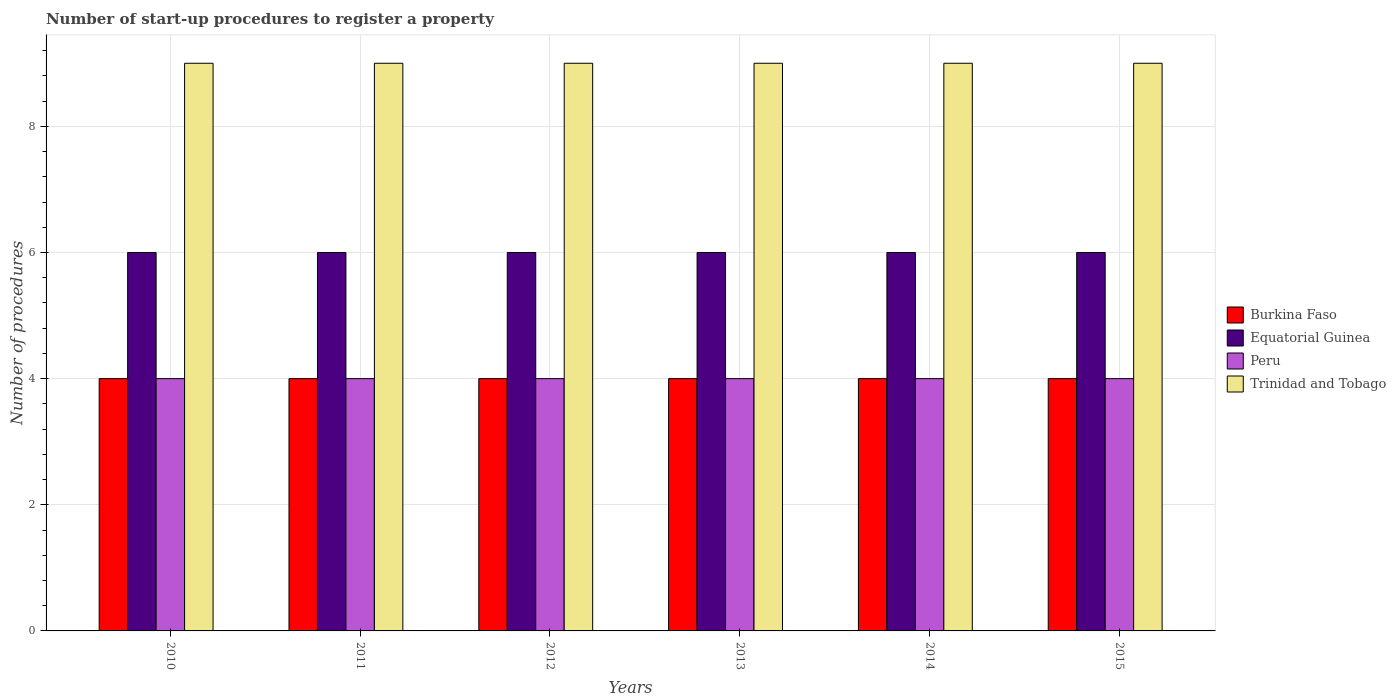How many groups of bars are there?
Give a very brief answer. 6. Are the number of bars on each tick of the X-axis equal?
Make the answer very short. Yes. What is the label of the 6th group of bars from the left?
Provide a short and direct response. 2015. Across all years, what is the maximum number of procedures required to register a property in Peru?
Provide a short and direct response. 4. Across all years, what is the minimum number of procedures required to register a property in Trinidad and Tobago?
Your response must be concise. 9. In which year was the number of procedures required to register a property in Equatorial Guinea minimum?
Offer a terse response. 2010. What is the total number of procedures required to register a property in Peru in the graph?
Keep it short and to the point. 24. What is the difference between the number of procedures required to register a property in Trinidad and Tobago in 2010 and that in 2014?
Provide a succinct answer. 0. In the year 2010, what is the difference between the number of procedures required to register a property in Trinidad and Tobago and number of procedures required to register a property in Peru?
Offer a terse response. 5. In how many years, is the number of procedures required to register a property in Trinidad and Tobago greater than 4.8?
Ensure brevity in your answer.  6. Is the difference between the number of procedures required to register a property in Trinidad and Tobago in 2013 and 2015 greater than the difference between the number of procedures required to register a property in Peru in 2013 and 2015?
Your response must be concise. No. What is the difference between the highest and the lowest number of procedures required to register a property in Peru?
Provide a short and direct response. 0. Is the sum of the number of procedures required to register a property in Peru in 2010 and 2014 greater than the maximum number of procedures required to register a property in Equatorial Guinea across all years?
Make the answer very short. Yes. Is it the case that in every year, the sum of the number of procedures required to register a property in Burkina Faso and number of procedures required to register a property in Trinidad and Tobago is greater than the sum of number of procedures required to register a property in Equatorial Guinea and number of procedures required to register a property in Peru?
Provide a succinct answer. Yes. What does the 2nd bar from the left in 2010 represents?
Ensure brevity in your answer.  Equatorial Guinea. What does the 4th bar from the right in 2014 represents?
Provide a short and direct response. Burkina Faso. How many bars are there?
Your answer should be compact. 24. How many years are there in the graph?
Make the answer very short. 6. What is the difference between two consecutive major ticks on the Y-axis?
Make the answer very short. 2. How many legend labels are there?
Provide a succinct answer. 4. What is the title of the graph?
Offer a very short reply. Number of start-up procedures to register a property. Does "Central Europe" appear as one of the legend labels in the graph?
Offer a terse response. No. What is the label or title of the X-axis?
Your response must be concise. Years. What is the label or title of the Y-axis?
Give a very brief answer. Number of procedures. What is the Number of procedures of Burkina Faso in 2010?
Your answer should be very brief. 4. What is the Number of procedures of Equatorial Guinea in 2010?
Offer a very short reply. 6. What is the Number of procedures of Peru in 2010?
Provide a succinct answer. 4. What is the Number of procedures of Trinidad and Tobago in 2010?
Your answer should be compact. 9. What is the Number of procedures in Peru in 2011?
Offer a very short reply. 4. What is the Number of procedures in Trinidad and Tobago in 2011?
Offer a very short reply. 9. What is the Number of procedures in Equatorial Guinea in 2013?
Offer a very short reply. 6. What is the Number of procedures of Trinidad and Tobago in 2013?
Provide a short and direct response. 9. What is the Number of procedures of Equatorial Guinea in 2014?
Give a very brief answer. 6. What is the Number of procedures in Peru in 2014?
Keep it short and to the point. 4. What is the Number of procedures in Burkina Faso in 2015?
Offer a very short reply. 4. What is the Number of procedures of Equatorial Guinea in 2015?
Offer a terse response. 6. What is the Number of procedures of Peru in 2015?
Your answer should be very brief. 4. Across all years, what is the minimum Number of procedures in Trinidad and Tobago?
Give a very brief answer. 9. What is the total Number of procedures in Burkina Faso in the graph?
Ensure brevity in your answer.  24. What is the total Number of procedures in Equatorial Guinea in the graph?
Your answer should be very brief. 36. What is the total Number of procedures of Peru in the graph?
Keep it short and to the point. 24. What is the difference between the Number of procedures in Equatorial Guinea in 2010 and that in 2011?
Give a very brief answer. 0. What is the difference between the Number of procedures in Peru in 2010 and that in 2011?
Your answer should be very brief. 0. What is the difference between the Number of procedures in Trinidad and Tobago in 2010 and that in 2011?
Your response must be concise. 0. What is the difference between the Number of procedures in Burkina Faso in 2010 and that in 2012?
Your response must be concise. 0. What is the difference between the Number of procedures in Equatorial Guinea in 2010 and that in 2012?
Your answer should be compact. 0. What is the difference between the Number of procedures in Peru in 2010 and that in 2012?
Keep it short and to the point. 0. What is the difference between the Number of procedures in Trinidad and Tobago in 2010 and that in 2012?
Keep it short and to the point. 0. What is the difference between the Number of procedures of Burkina Faso in 2010 and that in 2013?
Offer a very short reply. 0. What is the difference between the Number of procedures in Equatorial Guinea in 2010 and that in 2013?
Provide a short and direct response. 0. What is the difference between the Number of procedures of Burkina Faso in 2010 and that in 2014?
Ensure brevity in your answer.  0. What is the difference between the Number of procedures in Equatorial Guinea in 2010 and that in 2014?
Keep it short and to the point. 0. What is the difference between the Number of procedures in Equatorial Guinea in 2010 and that in 2015?
Give a very brief answer. 0. What is the difference between the Number of procedures of Peru in 2011 and that in 2012?
Ensure brevity in your answer.  0. What is the difference between the Number of procedures in Trinidad and Tobago in 2011 and that in 2014?
Offer a terse response. 0. What is the difference between the Number of procedures in Equatorial Guinea in 2011 and that in 2015?
Your response must be concise. 0. What is the difference between the Number of procedures in Peru in 2011 and that in 2015?
Offer a terse response. 0. What is the difference between the Number of procedures in Burkina Faso in 2012 and that in 2013?
Offer a very short reply. 0. What is the difference between the Number of procedures of Equatorial Guinea in 2012 and that in 2013?
Give a very brief answer. 0. What is the difference between the Number of procedures of Peru in 2012 and that in 2013?
Your answer should be very brief. 0. What is the difference between the Number of procedures of Burkina Faso in 2012 and that in 2014?
Provide a short and direct response. 0. What is the difference between the Number of procedures in Burkina Faso in 2012 and that in 2015?
Offer a very short reply. 0. What is the difference between the Number of procedures of Equatorial Guinea in 2012 and that in 2015?
Provide a short and direct response. 0. What is the difference between the Number of procedures in Trinidad and Tobago in 2012 and that in 2015?
Give a very brief answer. 0. What is the difference between the Number of procedures of Burkina Faso in 2013 and that in 2014?
Ensure brevity in your answer.  0. What is the difference between the Number of procedures of Burkina Faso in 2013 and that in 2015?
Offer a terse response. 0. What is the difference between the Number of procedures in Equatorial Guinea in 2013 and that in 2015?
Your answer should be compact. 0. What is the difference between the Number of procedures of Peru in 2013 and that in 2015?
Provide a short and direct response. 0. What is the difference between the Number of procedures in Trinidad and Tobago in 2013 and that in 2015?
Your answer should be very brief. 0. What is the difference between the Number of procedures in Burkina Faso in 2014 and that in 2015?
Your answer should be compact. 0. What is the difference between the Number of procedures in Peru in 2014 and that in 2015?
Offer a very short reply. 0. What is the difference between the Number of procedures in Trinidad and Tobago in 2014 and that in 2015?
Offer a very short reply. 0. What is the difference between the Number of procedures in Burkina Faso in 2010 and the Number of procedures in Equatorial Guinea in 2011?
Provide a succinct answer. -2. What is the difference between the Number of procedures in Peru in 2010 and the Number of procedures in Trinidad and Tobago in 2011?
Ensure brevity in your answer.  -5. What is the difference between the Number of procedures of Burkina Faso in 2010 and the Number of procedures of Equatorial Guinea in 2012?
Provide a short and direct response. -2. What is the difference between the Number of procedures in Burkina Faso in 2010 and the Number of procedures in Peru in 2012?
Provide a short and direct response. 0. What is the difference between the Number of procedures of Burkina Faso in 2010 and the Number of procedures of Trinidad and Tobago in 2012?
Keep it short and to the point. -5. What is the difference between the Number of procedures of Equatorial Guinea in 2010 and the Number of procedures of Peru in 2012?
Ensure brevity in your answer.  2. What is the difference between the Number of procedures of Equatorial Guinea in 2010 and the Number of procedures of Trinidad and Tobago in 2012?
Your answer should be very brief. -3. What is the difference between the Number of procedures of Burkina Faso in 2010 and the Number of procedures of Peru in 2013?
Keep it short and to the point. 0. What is the difference between the Number of procedures in Burkina Faso in 2010 and the Number of procedures in Trinidad and Tobago in 2013?
Keep it short and to the point. -5. What is the difference between the Number of procedures of Burkina Faso in 2010 and the Number of procedures of Equatorial Guinea in 2014?
Provide a succinct answer. -2. What is the difference between the Number of procedures of Burkina Faso in 2010 and the Number of procedures of Peru in 2014?
Your response must be concise. 0. What is the difference between the Number of procedures in Burkina Faso in 2010 and the Number of procedures in Trinidad and Tobago in 2014?
Your answer should be compact. -5. What is the difference between the Number of procedures of Peru in 2010 and the Number of procedures of Trinidad and Tobago in 2014?
Your answer should be very brief. -5. What is the difference between the Number of procedures of Burkina Faso in 2010 and the Number of procedures of Equatorial Guinea in 2015?
Keep it short and to the point. -2. What is the difference between the Number of procedures of Burkina Faso in 2010 and the Number of procedures of Peru in 2015?
Make the answer very short. 0. What is the difference between the Number of procedures in Burkina Faso in 2010 and the Number of procedures in Trinidad and Tobago in 2015?
Offer a very short reply. -5. What is the difference between the Number of procedures of Equatorial Guinea in 2010 and the Number of procedures of Trinidad and Tobago in 2015?
Your response must be concise. -3. What is the difference between the Number of procedures in Peru in 2010 and the Number of procedures in Trinidad and Tobago in 2015?
Make the answer very short. -5. What is the difference between the Number of procedures of Burkina Faso in 2011 and the Number of procedures of Peru in 2012?
Keep it short and to the point. 0. What is the difference between the Number of procedures in Equatorial Guinea in 2011 and the Number of procedures in Peru in 2012?
Your answer should be compact. 2. What is the difference between the Number of procedures in Equatorial Guinea in 2011 and the Number of procedures in Trinidad and Tobago in 2012?
Offer a very short reply. -3. What is the difference between the Number of procedures of Peru in 2011 and the Number of procedures of Trinidad and Tobago in 2012?
Provide a succinct answer. -5. What is the difference between the Number of procedures of Burkina Faso in 2011 and the Number of procedures of Peru in 2013?
Provide a short and direct response. 0. What is the difference between the Number of procedures in Burkina Faso in 2011 and the Number of procedures in Trinidad and Tobago in 2013?
Offer a terse response. -5. What is the difference between the Number of procedures of Equatorial Guinea in 2011 and the Number of procedures of Trinidad and Tobago in 2013?
Your response must be concise. -3. What is the difference between the Number of procedures in Peru in 2011 and the Number of procedures in Trinidad and Tobago in 2013?
Offer a very short reply. -5. What is the difference between the Number of procedures in Burkina Faso in 2011 and the Number of procedures in Equatorial Guinea in 2014?
Your answer should be very brief. -2. What is the difference between the Number of procedures of Burkina Faso in 2011 and the Number of procedures of Peru in 2014?
Your answer should be compact. 0. What is the difference between the Number of procedures of Equatorial Guinea in 2011 and the Number of procedures of Peru in 2014?
Offer a very short reply. 2. What is the difference between the Number of procedures of Equatorial Guinea in 2011 and the Number of procedures of Trinidad and Tobago in 2014?
Provide a short and direct response. -3. What is the difference between the Number of procedures of Burkina Faso in 2011 and the Number of procedures of Equatorial Guinea in 2015?
Provide a short and direct response. -2. What is the difference between the Number of procedures of Burkina Faso in 2011 and the Number of procedures of Peru in 2015?
Offer a very short reply. 0. What is the difference between the Number of procedures of Equatorial Guinea in 2011 and the Number of procedures of Peru in 2015?
Provide a short and direct response. 2. What is the difference between the Number of procedures in Equatorial Guinea in 2011 and the Number of procedures in Trinidad and Tobago in 2015?
Your answer should be compact. -3. What is the difference between the Number of procedures in Peru in 2011 and the Number of procedures in Trinidad and Tobago in 2015?
Provide a succinct answer. -5. What is the difference between the Number of procedures in Burkina Faso in 2012 and the Number of procedures in Equatorial Guinea in 2013?
Offer a very short reply. -2. What is the difference between the Number of procedures of Burkina Faso in 2012 and the Number of procedures of Trinidad and Tobago in 2013?
Your answer should be compact. -5. What is the difference between the Number of procedures in Equatorial Guinea in 2012 and the Number of procedures in Trinidad and Tobago in 2013?
Keep it short and to the point. -3. What is the difference between the Number of procedures of Burkina Faso in 2012 and the Number of procedures of Equatorial Guinea in 2014?
Offer a very short reply. -2. What is the difference between the Number of procedures in Burkina Faso in 2012 and the Number of procedures in Peru in 2014?
Keep it short and to the point. 0. What is the difference between the Number of procedures of Equatorial Guinea in 2012 and the Number of procedures of Trinidad and Tobago in 2014?
Your response must be concise. -3. What is the difference between the Number of procedures in Equatorial Guinea in 2012 and the Number of procedures in Peru in 2015?
Give a very brief answer. 2. What is the difference between the Number of procedures of Burkina Faso in 2013 and the Number of procedures of Equatorial Guinea in 2014?
Ensure brevity in your answer.  -2. What is the difference between the Number of procedures of Equatorial Guinea in 2013 and the Number of procedures of Peru in 2014?
Provide a succinct answer. 2. What is the difference between the Number of procedures in Equatorial Guinea in 2013 and the Number of procedures in Trinidad and Tobago in 2014?
Your answer should be very brief. -3. What is the difference between the Number of procedures in Peru in 2013 and the Number of procedures in Trinidad and Tobago in 2014?
Your answer should be very brief. -5. What is the difference between the Number of procedures in Burkina Faso in 2013 and the Number of procedures in Peru in 2015?
Your response must be concise. 0. What is the difference between the Number of procedures in Equatorial Guinea in 2013 and the Number of procedures in Peru in 2015?
Your answer should be compact. 2. What is the difference between the Number of procedures of Peru in 2013 and the Number of procedures of Trinidad and Tobago in 2015?
Your answer should be very brief. -5. What is the difference between the Number of procedures of Burkina Faso in 2014 and the Number of procedures of Peru in 2015?
Ensure brevity in your answer.  0. What is the difference between the Number of procedures of Burkina Faso in 2014 and the Number of procedures of Trinidad and Tobago in 2015?
Provide a succinct answer. -5. What is the average Number of procedures in Burkina Faso per year?
Offer a terse response. 4. What is the average Number of procedures of Trinidad and Tobago per year?
Keep it short and to the point. 9. In the year 2010, what is the difference between the Number of procedures in Burkina Faso and Number of procedures in Equatorial Guinea?
Make the answer very short. -2. In the year 2010, what is the difference between the Number of procedures in Burkina Faso and Number of procedures in Peru?
Your answer should be compact. 0. In the year 2010, what is the difference between the Number of procedures in Equatorial Guinea and Number of procedures in Peru?
Offer a very short reply. 2. In the year 2010, what is the difference between the Number of procedures of Equatorial Guinea and Number of procedures of Trinidad and Tobago?
Provide a short and direct response. -3. In the year 2010, what is the difference between the Number of procedures in Peru and Number of procedures in Trinidad and Tobago?
Offer a terse response. -5. In the year 2011, what is the difference between the Number of procedures in Burkina Faso and Number of procedures in Equatorial Guinea?
Offer a terse response. -2. In the year 2011, what is the difference between the Number of procedures of Burkina Faso and Number of procedures of Trinidad and Tobago?
Your answer should be very brief. -5. In the year 2011, what is the difference between the Number of procedures of Equatorial Guinea and Number of procedures of Trinidad and Tobago?
Keep it short and to the point. -3. In the year 2011, what is the difference between the Number of procedures of Peru and Number of procedures of Trinidad and Tobago?
Offer a terse response. -5. In the year 2012, what is the difference between the Number of procedures of Burkina Faso and Number of procedures of Trinidad and Tobago?
Offer a very short reply. -5. In the year 2012, what is the difference between the Number of procedures in Equatorial Guinea and Number of procedures in Trinidad and Tobago?
Offer a very short reply. -3. In the year 2012, what is the difference between the Number of procedures of Peru and Number of procedures of Trinidad and Tobago?
Offer a very short reply. -5. In the year 2013, what is the difference between the Number of procedures in Burkina Faso and Number of procedures in Equatorial Guinea?
Provide a succinct answer. -2. In the year 2013, what is the difference between the Number of procedures of Equatorial Guinea and Number of procedures of Peru?
Keep it short and to the point. 2. In the year 2014, what is the difference between the Number of procedures in Burkina Faso and Number of procedures in Equatorial Guinea?
Provide a short and direct response. -2. In the year 2014, what is the difference between the Number of procedures in Equatorial Guinea and Number of procedures in Trinidad and Tobago?
Your answer should be compact. -3. In the year 2014, what is the difference between the Number of procedures in Peru and Number of procedures in Trinidad and Tobago?
Offer a very short reply. -5. In the year 2015, what is the difference between the Number of procedures of Burkina Faso and Number of procedures of Peru?
Ensure brevity in your answer.  0. In the year 2015, what is the difference between the Number of procedures of Equatorial Guinea and Number of procedures of Peru?
Give a very brief answer. 2. In the year 2015, what is the difference between the Number of procedures in Equatorial Guinea and Number of procedures in Trinidad and Tobago?
Your answer should be compact. -3. In the year 2015, what is the difference between the Number of procedures in Peru and Number of procedures in Trinidad and Tobago?
Give a very brief answer. -5. What is the ratio of the Number of procedures in Equatorial Guinea in 2010 to that in 2011?
Provide a succinct answer. 1. What is the ratio of the Number of procedures in Trinidad and Tobago in 2010 to that in 2011?
Ensure brevity in your answer.  1. What is the ratio of the Number of procedures of Burkina Faso in 2010 to that in 2012?
Offer a terse response. 1. What is the ratio of the Number of procedures of Equatorial Guinea in 2010 to that in 2012?
Make the answer very short. 1. What is the ratio of the Number of procedures in Peru in 2010 to that in 2012?
Your response must be concise. 1. What is the ratio of the Number of procedures in Trinidad and Tobago in 2010 to that in 2012?
Offer a terse response. 1. What is the ratio of the Number of procedures of Burkina Faso in 2010 to that in 2013?
Your response must be concise. 1. What is the ratio of the Number of procedures of Peru in 2010 to that in 2013?
Provide a short and direct response. 1. What is the ratio of the Number of procedures in Trinidad and Tobago in 2010 to that in 2013?
Offer a terse response. 1. What is the ratio of the Number of procedures in Equatorial Guinea in 2010 to that in 2015?
Give a very brief answer. 1. What is the ratio of the Number of procedures of Peru in 2010 to that in 2015?
Provide a short and direct response. 1. What is the ratio of the Number of procedures of Trinidad and Tobago in 2010 to that in 2015?
Give a very brief answer. 1. What is the ratio of the Number of procedures of Equatorial Guinea in 2011 to that in 2012?
Keep it short and to the point. 1. What is the ratio of the Number of procedures of Peru in 2011 to that in 2012?
Make the answer very short. 1. What is the ratio of the Number of procedures of Trinidad and Tobago in 2011 to that in 2012?
Your answer should be very brief. 1. What is the ratio of the Number of procedures of Equatorial Guinea in 2011 to that in 2013?
Offer a terse response. 1. What is the ratio of the Number of procedures of Trinidad and Tobago in 2011 to that in 2014?
Provide a short and direct response. 1. What is the ratio of the Number of procedures in Burkina Faso in 2011 to that in 2015?
Offer a terse response. 1. What is the ratio of the Number of procedures in Equatorial Guinea in 2011 to that in 2015?
Provide a short and direct response. 1. What is the ratio of the Number of procedures in Peru in 2011 to that in 2015?
Your response must be concise. 1. What is the ratio of the Number of procedures of Trinidad and Tobago in 2011 to that in 2015?
Provide a short and direct response. 1. What is the ratio of the Number of procedures in Burkina Faso in 2012 to that in 2013?
Provide a short and direct response. 1. What is the ratio of the Number of procedures of Equatorial Guinea in 2012 to that in 2013?
Keep it short and to the point. 1. What is the ratio of the Number of procedures in Peru in 2012 to that in 2013?
Ensure brevity in your answer.  1. What is the ratio of the Number of procedures of Equatorial Guinea in 2012 to that in 2014?
Make the answer very short. 1. What is the ratio of the Number of procedures of Trinidad and Tobago in 2012 to that in 2014?
Keep it short and to the point. 1. What is the ratio of the Number of procedures in Peru in 2012 to that in 2015?
Ensure brevity in your answer.  1. What is the ratio of the Number of procedures of Trinidad and Tobago in 2012 to that in 2015?
Your answer should be compact. 1. What is the ratio of the Number of procedures of Equatorial Guinea in 2013 to that in 2014?
Provide a succinct answer. 1. What is the ratio of the Number of procedures in Peru in 2013 to that in 2014?
Provide a succinct answer. 1. What is the ratio of the Number of procedures of Trinidad and Tobago in 2013 to that in 2014?
Provide a succinct answer. 1. What is the ratio of the Number of procedures of Burkina Faso in 2013 to that in 2015?
Provide a short and direct response. 1. What is the ratio of the Number of procedures of Equatorial Guinea in 2013 to that in 2015?
Offer a very short reply. 1. What is the ratio of the Number of procedures of Trinidad and Tobago in 2013 to that in 2015?
Provide a succinct answer. 1. What is the ratio of the Number of procedures in Equatorial Guinea in 2014 to that in 2015?
Your answer should be compact. 1. What is the ratio of the Number of procedures of Peru in 2014 to that in 2015?
Offer a terse response. 1. What is the difference between the highest and the second highest Number of procedures in Burkina Faso?
Your answer should be very brief. 0. What is the difference between the highest and the lowest Number of procedures of Trinidad and Tobago?
Keep it short and to the point. 0. 